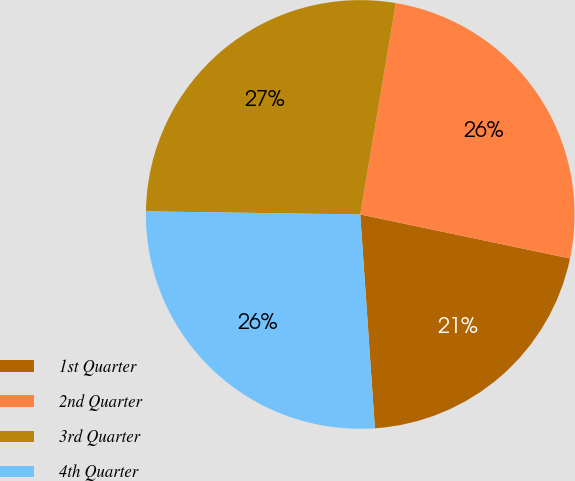<chart> <loc_0><loc_0><loc_500><loc_500><pie_chart><fcel>1st Quarter<fcel>2nd Quarter<fcel>3rd Quarter<fcel>4th Quarter<nl><fcel>20.62%<fcel>25.64%<fcel>27.43%<fcel>26.32%<nl></chart> 